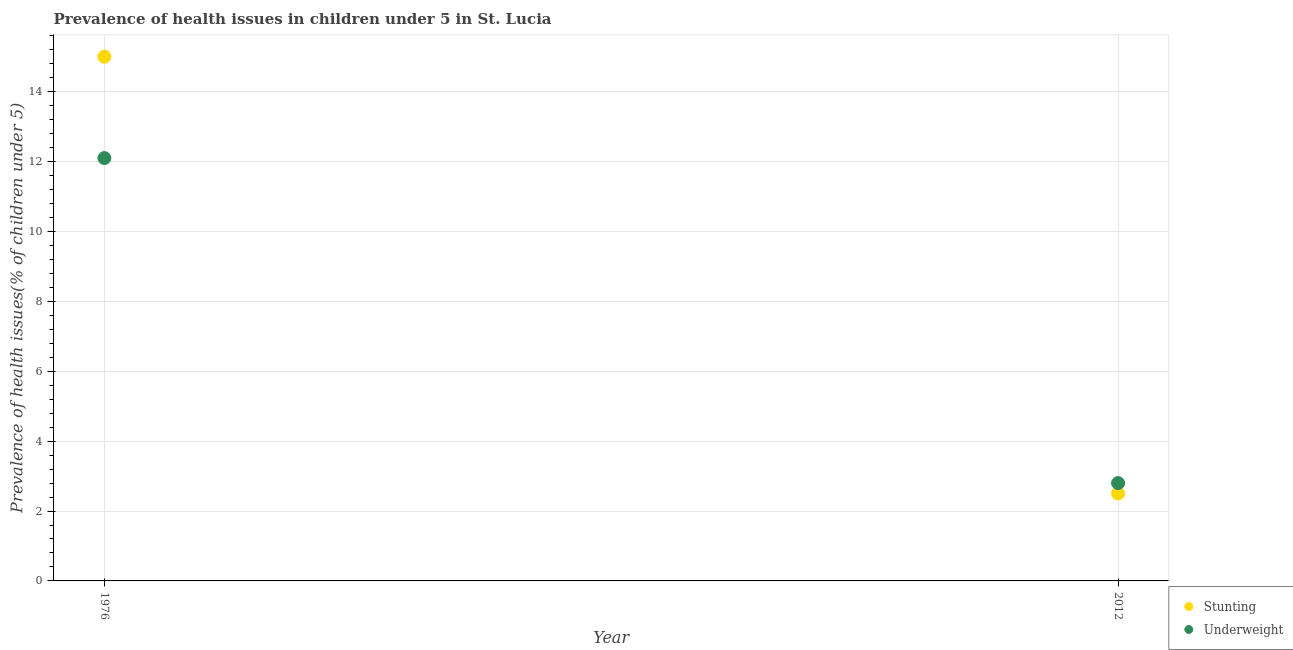What is the percentage of stunted children in 2012?
Offer a terse response. 2.5. Across all years, what is the maximum percentage of stunted children?
Your answer should be compact. 15. In which year was the percentage of underweight children maximum?
Your answer should be compact. 1976. What is the difference between the percentage of underweight children in 1976 and that in 2012?
Your response must be concise. 9.3. What is the difference between the percentage of stunted children in 1976 and the percentage of underweight children in 2012?
Provide a short and direct response. 12.2. What is the average percentage of underweight children per year?
Provide a succinct answer. 7.45. In the year 2012, what is the difference between the percentage of underweight children and percentage of stunted children?
Your response must be concise. 0.3. In how many years, is the percentage of underweight children greater than the average percentage of underweight children taken over all years?
Make the answer very short. 1. Does the percentage of stunted children monotonically increase over the years?
Your response must be concise. No. Is the percentage of stunted children strictly greater than the percentage of underweight children over the years?
Your answer should be very brief. No. Is the percentage of stunted children strictly less than the percentage of underweight children over the years?
Give a very brief answer. No. How many years are there in the graph?
Provide a succinct answer. 2. What is the difference between two consecutive major ticks on the Y-axis?
Offer a very short reply. 2. Are the values on the major ticks of Y-axis written in scientific E-notation?
Your answer should be compact. No. Does the graph contain any zero values?
Your response must be concise. No. Does the graph contain grids?
Make the answer very short. Yes. Where does the legend appear in the graph?
Provide a succinct answer. Bottom right. How many legend labels are there?
Make the answer very short. 2. What is the title of the graph?
Keep it short and to the point. Prevalence of health issues in children under 5 in St. Lucia. Does "Lowest 20% of population" appear as one of the legend labels in the graph?
Ensure brevity in your answer.  No. What is the label or title of the Y-axis?
Your response must be concise. Prevalence of health issues(% of children under 5). What is the Prevalence of health issues(% of children under 5) in Underweight in 1976?
Give a very brief answer. 12.1. What is the Prevalence of health issues(% of children under 5) in Underweight in 2012?
Your answer should be very brief. 2.8. Across all years, what is the maximum Prevalence of health issues(% of children under 5) of Underweight?
Provide a succinct answer. 12.1. Across all years, what is the minimum Prevalence of health issues(% of children under 5) of Underweight?
Your response must be concise. 2.8. What is the total Prevalence of health issues(% of children under 5) in Underweight in the graph?
Give a very brief answer. 14.9. What is the difference between the Prevalence of health issues(% of children under 5) of Underweight in 1976 and that in 2012?
Provide a succinct answer. 9.3. What is the average Prevalence of health issues(% of children under 5) of Stunting per year?
Give a very brief answer. 8.75. What is the average Prevalence of health issues(% of children under 5) of Underweight per year?
Give a very brief answer. 7.45. In the year 1976, what is the difference between the Prevalence of health issues(% of children under 5) in Stunting and Prevalence of health issues(% of children under 5) in Underweight?
Give a very brief answer. 2.9. In the year 2012, what is the difference between the Prevalence of health issues(% of children under 5) of Stunting and Prevalence of health issues(% of children under 5) of Underweight?
Offer a terse response. -0.3. What is the ratio of the Prevalence of health issues(% of children under 5) in Stunting in 1976 to that in 2012?
Provide a short and direct response. 6. What is the ratio of the Prevalence of health issues(% of children under 5) in Underweight in 1976 to that in 2012?
Your response must be concise. 4.32. What is the difference between the highest and the second highest Prevalence of health issues(% of children under 5) in Underweight?
Ensure brevity in your answer.  9.3. What is the difference between the highest and the lowest Prevalence of health issues(% of children under 5) of Underweight?
Offer a very short reply. 9.3. 